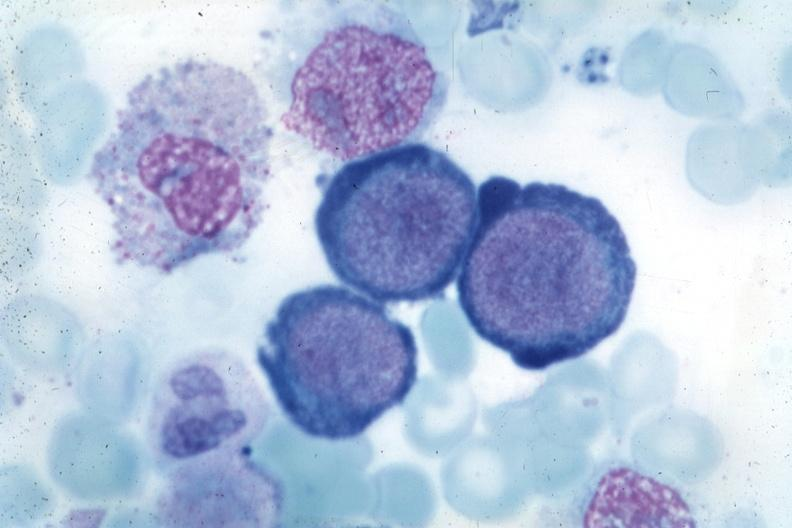s glioma present?
Answer the question using a single word or phrase. No 